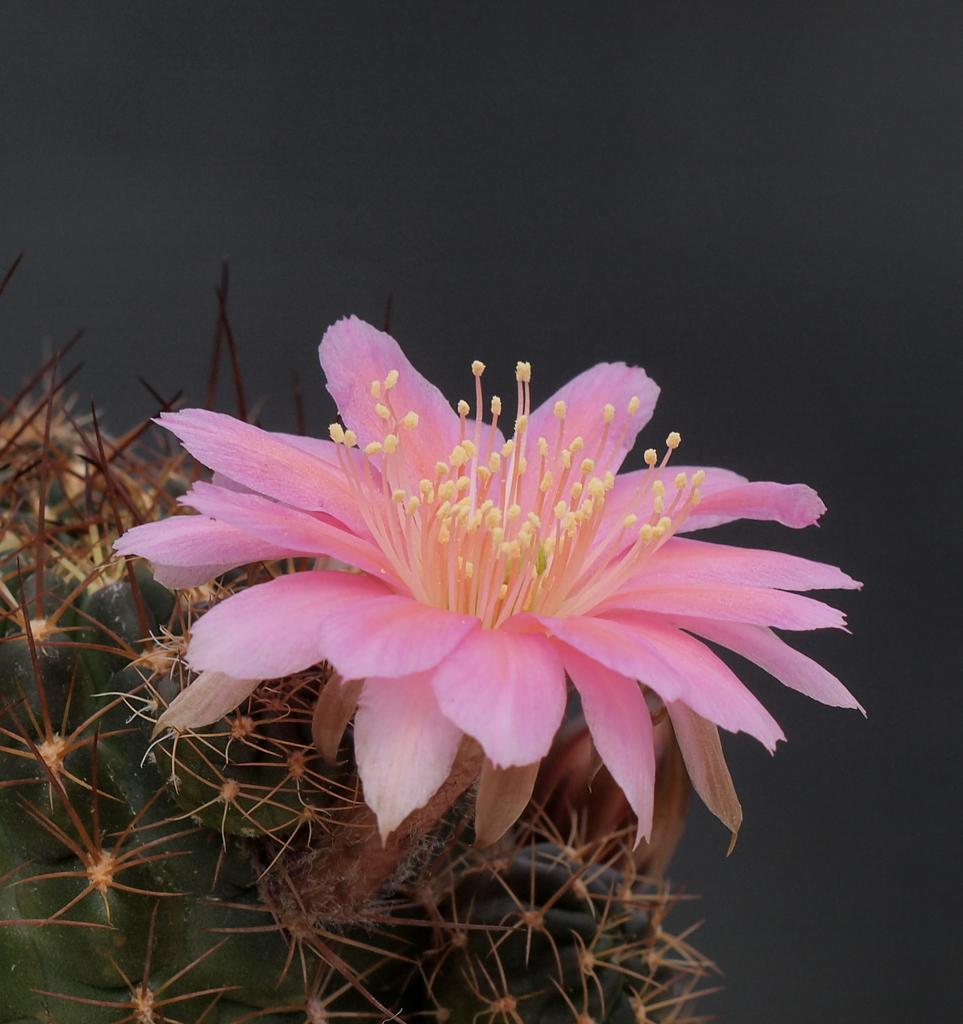In one or two sentences, can you explain what this image depicts? In this image we can see pink color flower. Left bottom of the image some green color stem like thing is there. 